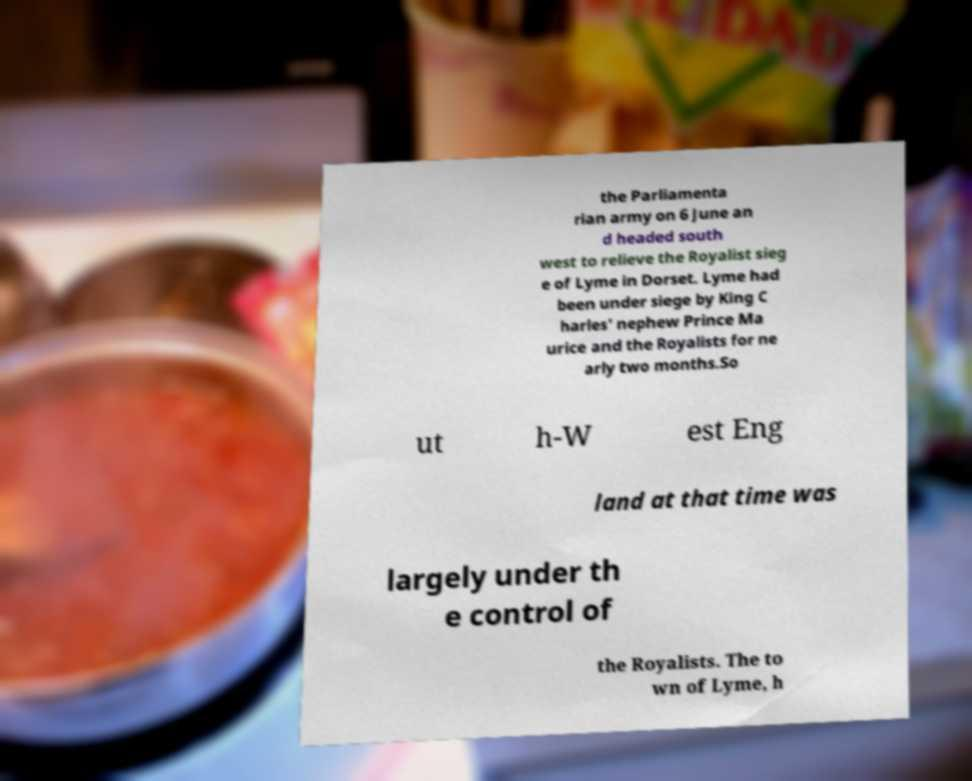Can you read and provide the text displayed in the image?This photo seems to have some interesting text. Can you extract and type it out for me? the Parliamenta rian army on 6 June an d headed south west to relieve the Royalist sieg e of Lyme in Dorset. Lyme had been under siege by King C harles' nephew Prince Ma urice and the Royalists for ne arly two months.So ut h-W est Eng land at that time was largely under th e control of the Royalists. The to wn of Lyme, h 